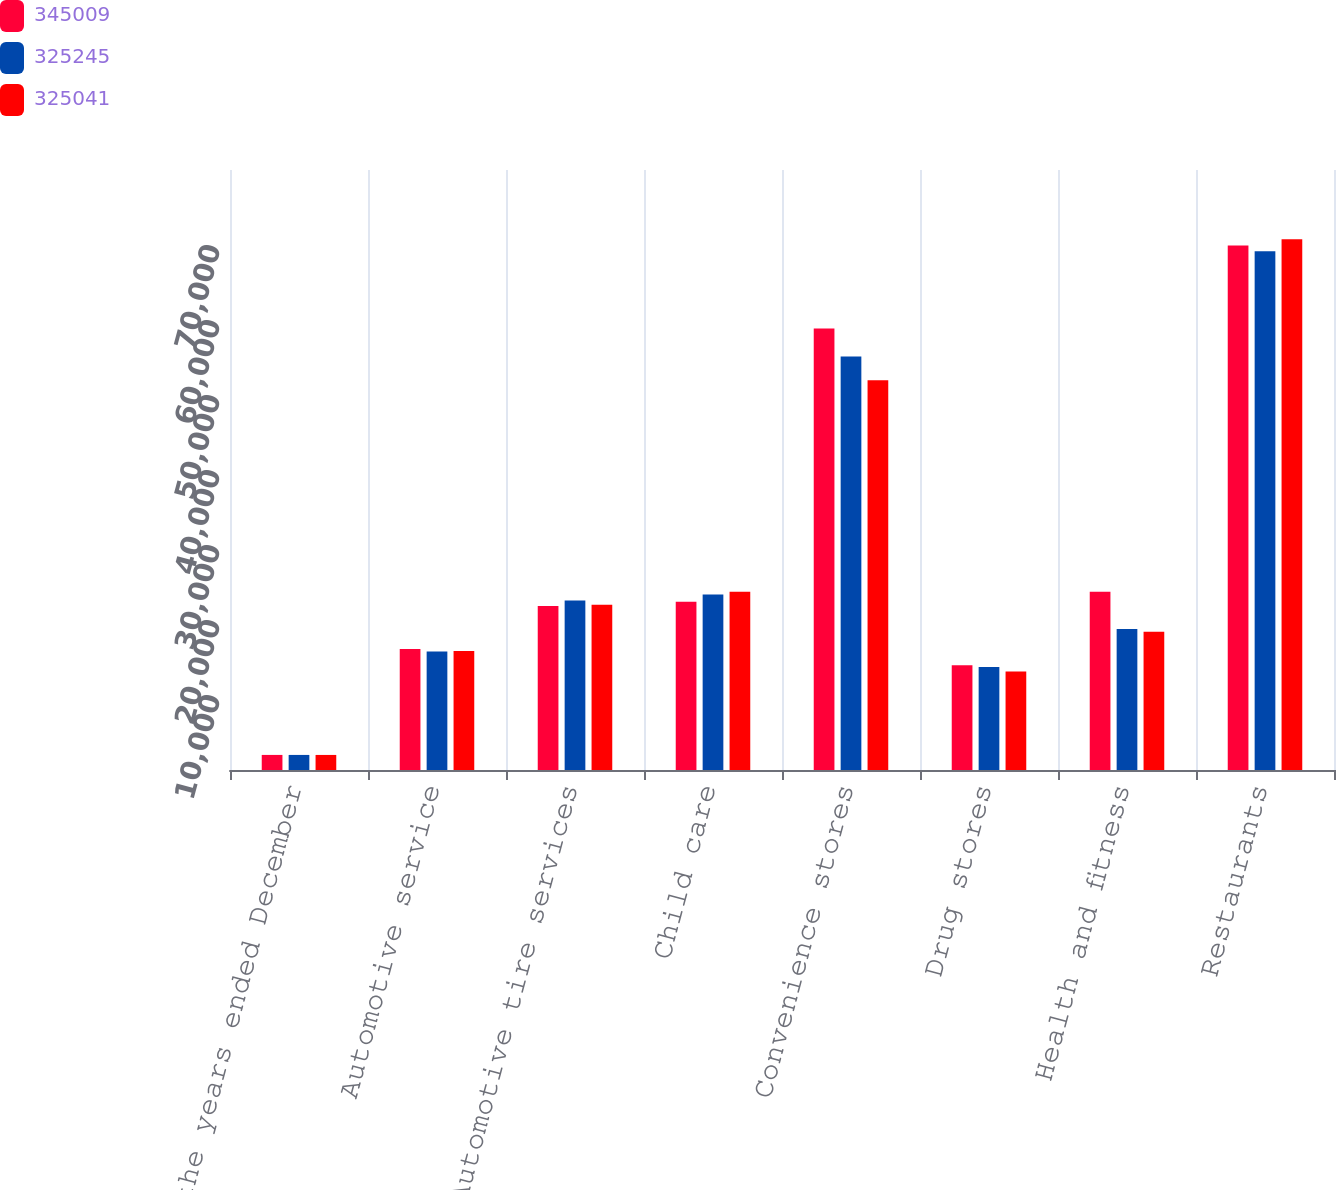Convert chart to OTSL. <chart><loc_0><loc_0><loc_500><loc_500><stacked_bar_chart><ecel><fcel>For the years ended December<fcel>Automotive service<fcel>Automotive tire services<fcel>Child care<fcel>Convenience stores<fcel>Drug stores<fcel>Health and fitness<fcel>Restaurants<nl><fcel>345009<fcel>2010<fcel>16123<fcel>21859<fcel>22417<fcel>58883<fcel>13962<fcel>23768<fcel>69923<nl><fcel>325245<fcel>2009<fcel>15797<fcel>22616<fcel>23408<fcel>55136<fcel>13727<fcel>18787<fcel>69181<nl><fcel>325041<fcel>2008<fcel>15853<fcel>22040<fcel>23758<fcel>51971<fcel>13125<fcel>18419<fcel>70763<nl></chart> 